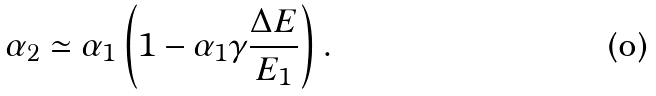Convert formula to latex. <formula><loc_0><loc_0><loc_500><loc_500>\alpha _ { 2 } \simeq \alpha _ { 1 } \left ( 1 - \alpha _ { 1 } \gamma \frac { \Delta E } { E _ { 1 } } \right ) .</formula> 